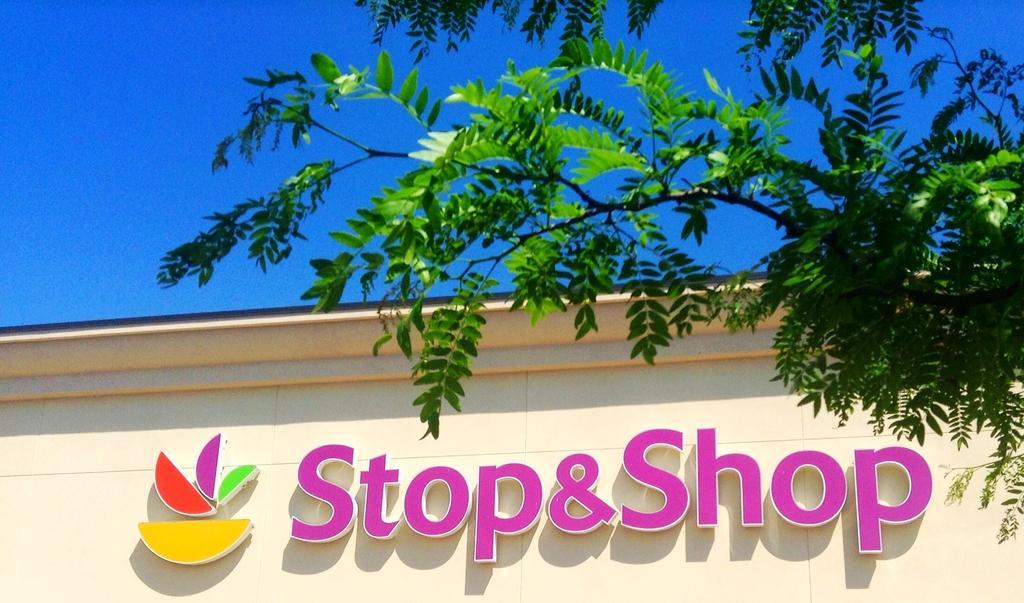Can you describe this image briefly? In this image we can see a letters board on the wall. Here we can see branches and leaves. In the background there is sky. 